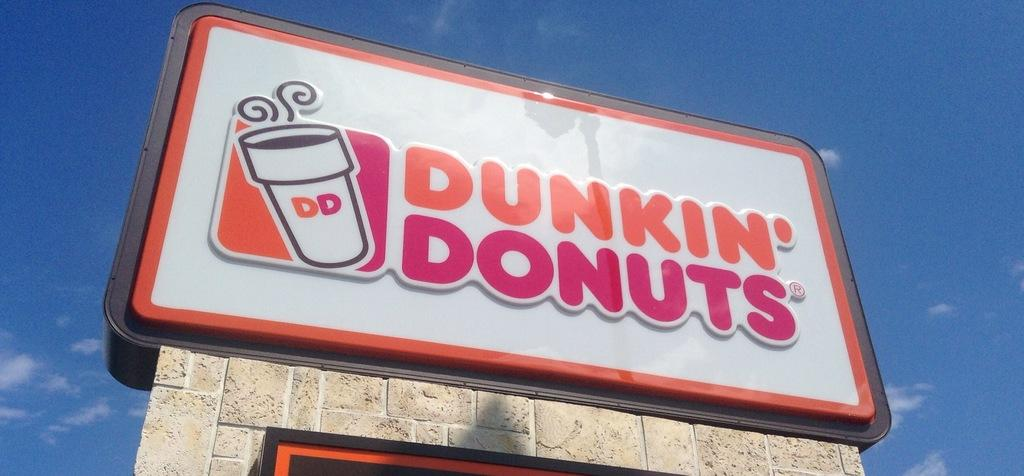<image>
Create a compact narrative representing the image presented. A large sign atop a stone pillar advertising Dunkin Donuts 